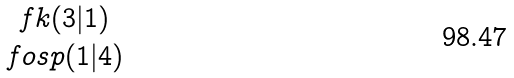Convert formula to latex. <formula><loc_0><loc_0><loc_500><loc_500>\begin{matrix} \ f k ( 3 | 1 ) \\ \ f o s p ( 1 | 4 ) \end{matrix}</formula> 